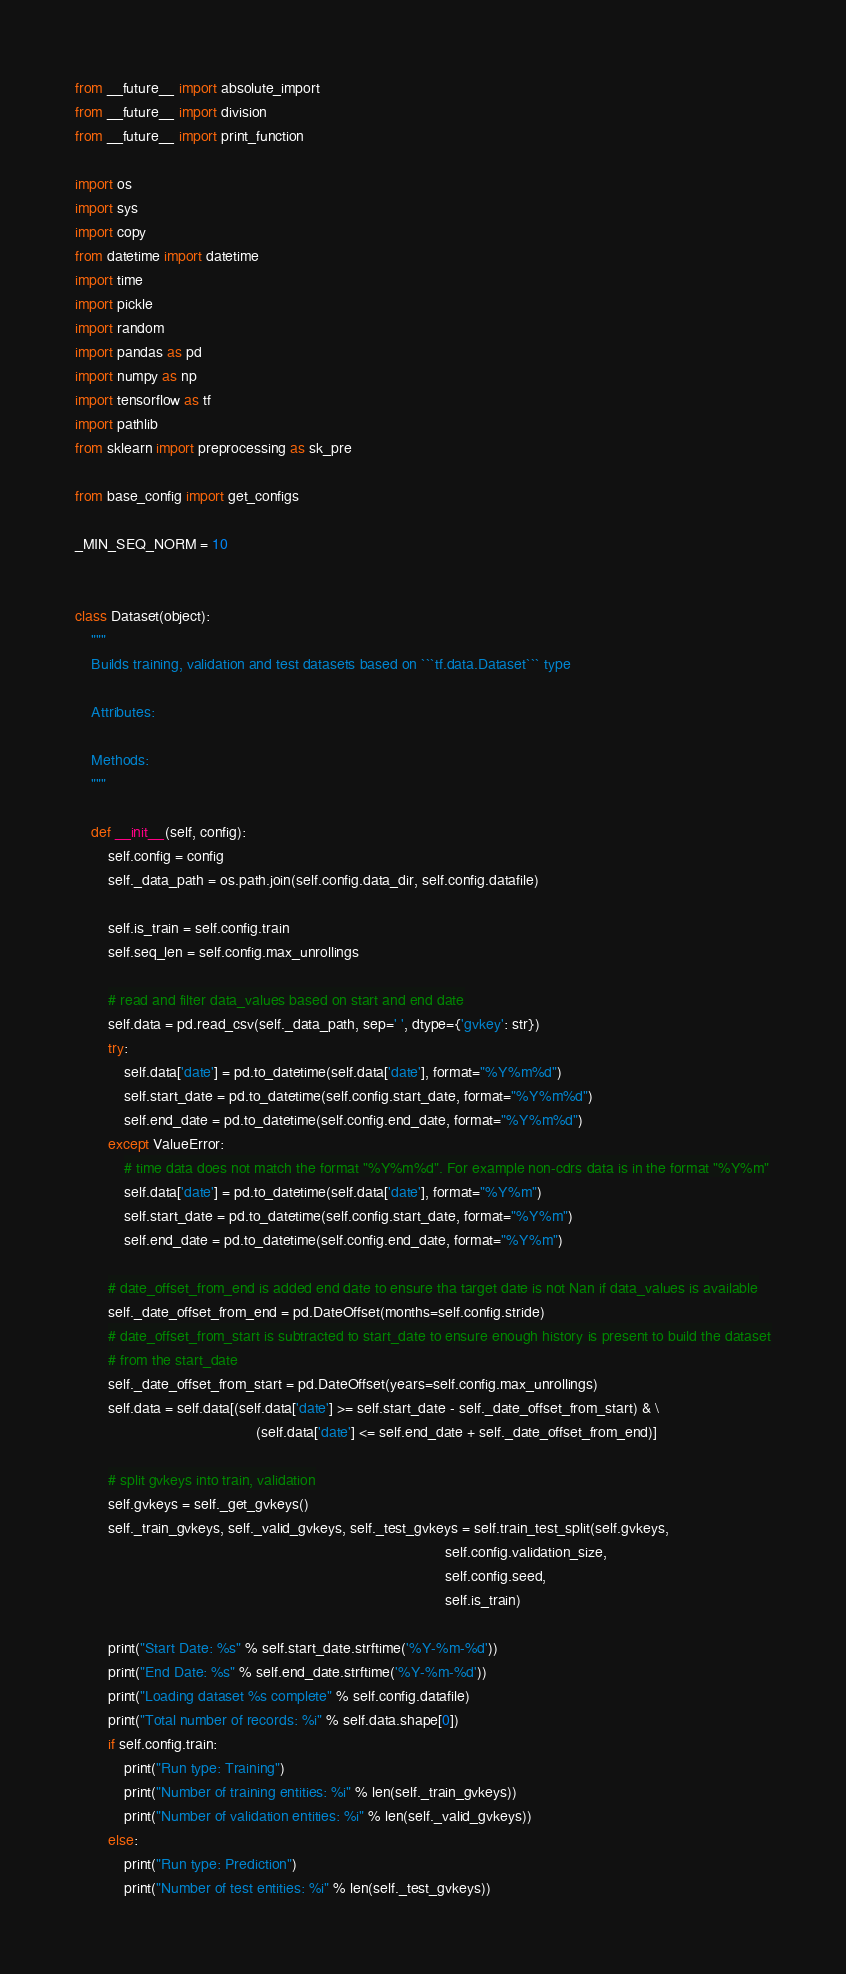Convert code to text. <code><loc_0><loc_0><loc_500><loc_500><_Python_>from __future__ import absolute_import
from __future__ import division
from __future__ import print_function

import os
import sys
import copy
from datetime import datetime
import time
import pickle
import random
import pandas as pd
import numpy as np
import tensorflow as tf
import pathlib
from sklearn import preprocessing as sk_pre

from base_config import get_configs

_MIN_SEQ_NORM = 10


class Dataset(object):
    """
    Builds training, validation and test datasets based on ```tf.data.Dataset``` type

    Attributes:

    Methods:
    """

    def __init__(self, config):
        self.config = config
        self._data_path = os.path.join(self.config.data_dir, self.config.datafile)

        self.is_train = self.config.train
        self.seq_len = self.config.max_unrollings

        # read and filter data_values based on start and end date
        self.data = pd.read_csv(self._data_path, sep=' ', dtype={'gvkey': str})
        try:
            self.data['date'] = pd.to_datetime(self.data['date'], format="%Y%m%d")
            self.start_date = pd.to_datetime(self.config.start_date, format="%Y%m%d")
            self.end_date = pd.to_datetime(self.config.end_date, format="%Y%m%d")
        except ValueError:
            # time data does not match the format "%Y%m%d". For example non-cdrs data is in the format "%Y%m"
            self.data['date'] = pd.to_datetime(self.data['date'], format="%Y%m")
            self.start_date = pd.to_datetime(self.config.start_date, format="%Y%m")
            self.end_date = pd.to_datetime(self.config.end_date, format="%Y%m")

        # date_offset_from_end is added end date to ensure tha target date is not Nan if data_values is available
        self._date_offset_from_end = pd.DateOffset(months=self.config.stride)
        # date_offset_from_start is subtracted to start_date to ensure enough history is present to build the dataset
        # from the start_date
        self._date_offset_from_start = pd.DateOffset(years=self.config.max_unrollings)
        self.data = self.data[(self.data['date'] >= self.start_date - self._date_offset_from_start) & \
                                            (self.data['date'] <= self.end_date + self._date_offset_from_end)]

        # split gvkeys into train, validation
        self.gvkeys = self._get_gvkeys()
        self._train_gvkeys, self._valid_gvkeys, self._test_gvkeys = self.train_test_split(self.gvkeys,
                                                                                          self.config.validation_size,
                                                                                          self.config.seed,
                                                                                          self.is_train)

        print("Start Date: %s" % self.start_date.strftime('%Y-%m-%d'))
        print("End Date: %s" % self.end_date.strftime('%Y-%m-%d'))
        print("Loading dataset %s complete" % self.config.datafile)
        print("Total number of records: %i" % self.data.shape[0])
        if self.config.train:
            print("Run type: Training")
            print("Number of training entities: %i" % len(self._train_gvkeys))
            print("Number of validation entities: %i" % len(self._valid_gvkeys))
        else:
            print("Run type: Prediction")
            print("Number of test entities: %i" % len(self._test_gvkeys))
</code> 